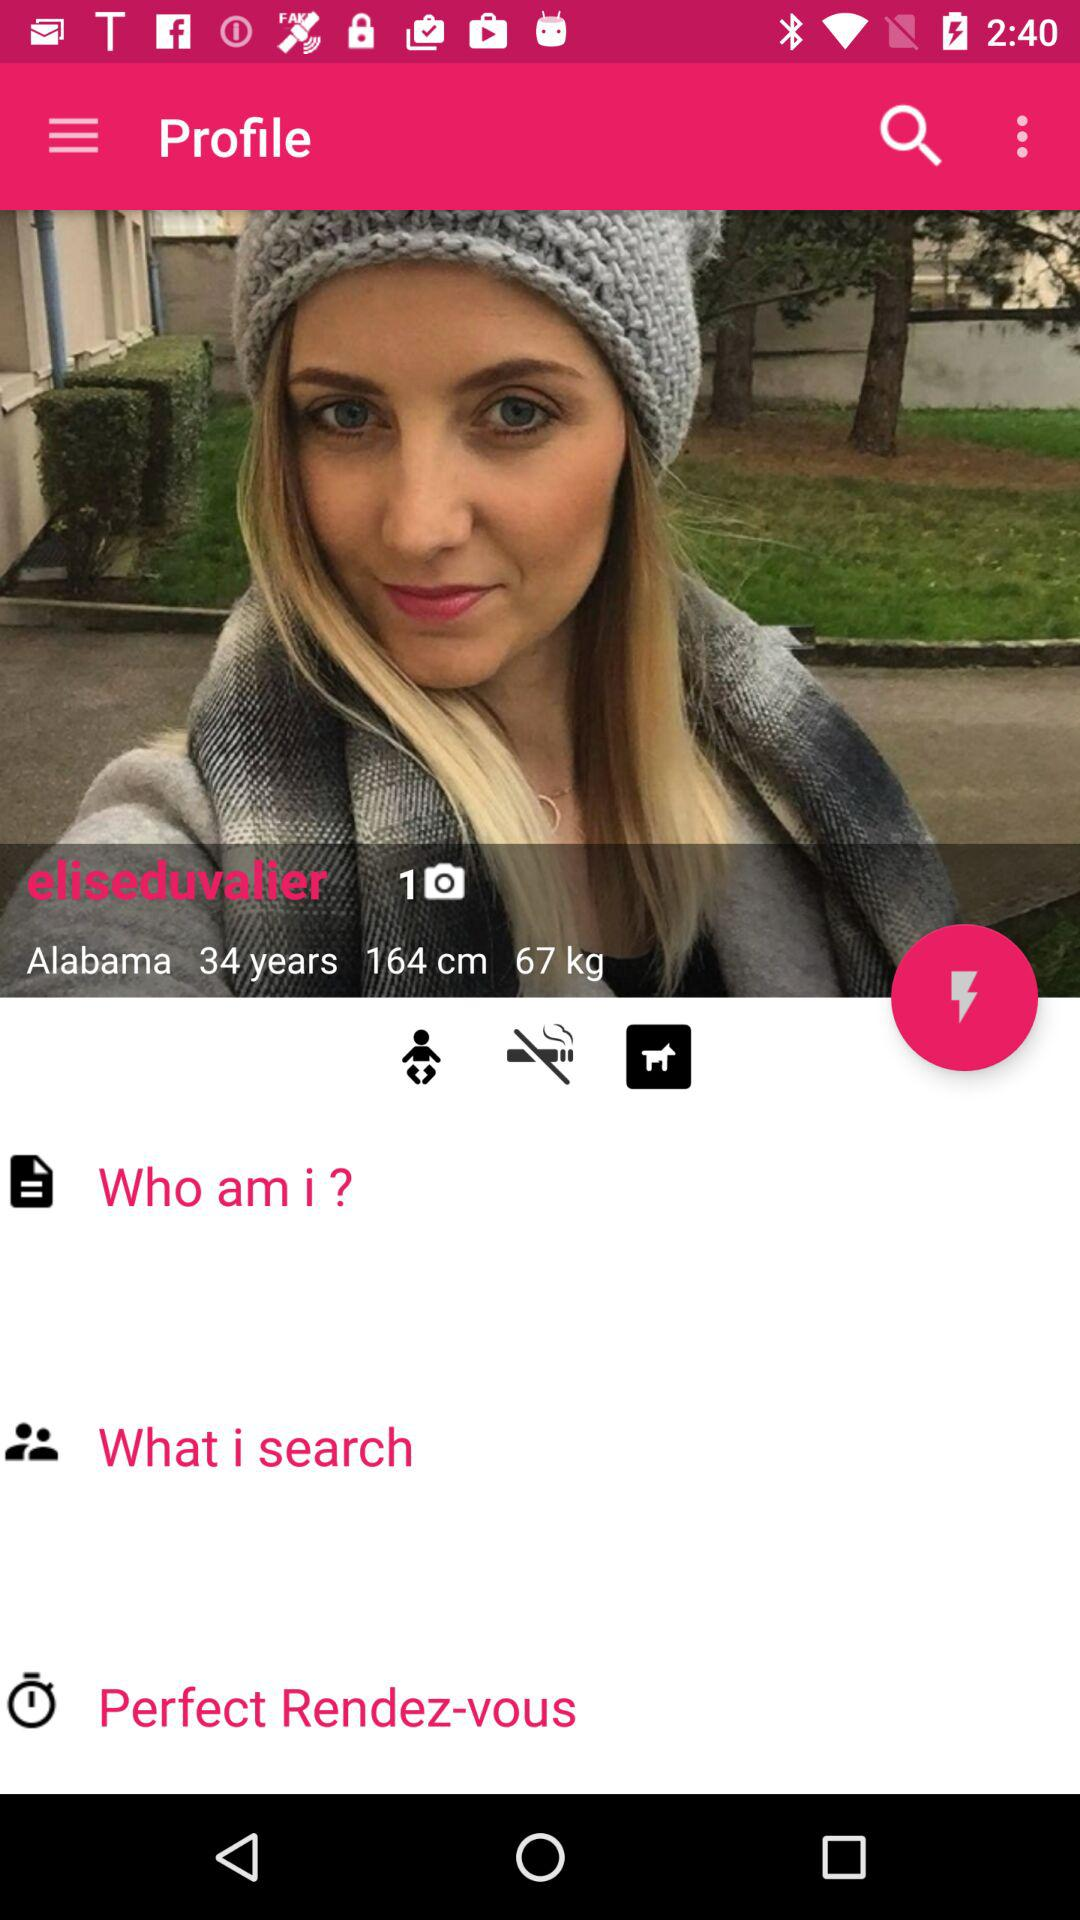What's the name of the girl? The name of the girl is "eliseduvalier". 